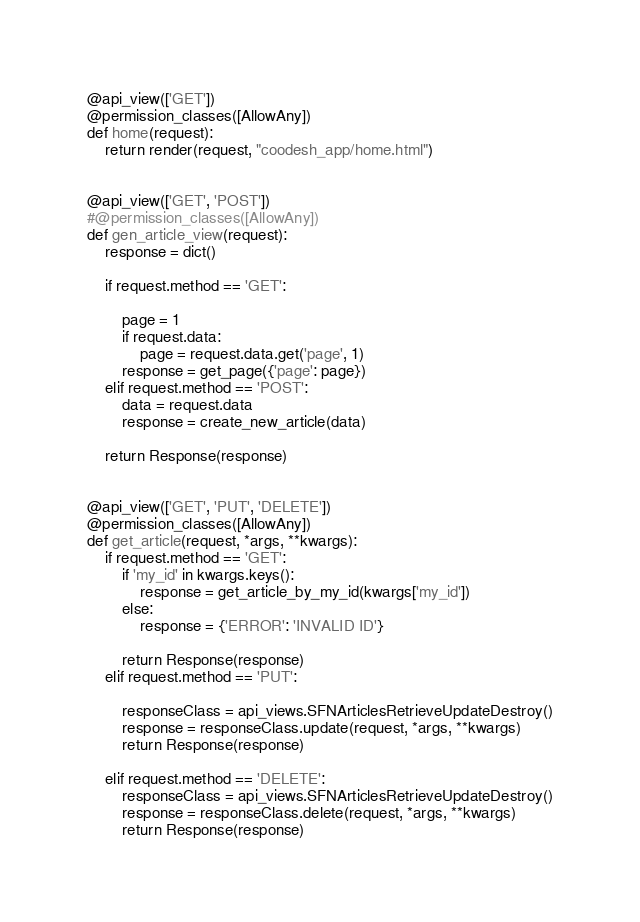Convert code to text. <code><loc_0><loc_0><loc_500><loc_500><_Python_>@api_view(['GET'])
@permission_classes([AllowAny])
def home(request):
    return render(request, "coodesh_app/home.html")


@api_view(['GET', 'POST'])
#@permission_classes([AllowAny])
def gen_article_view(request):
    response = dict()

    if request.method == 'GET':

        page = 1
        if request.data:
            page = request.data.get('page', 1)
        response = get_page({'page': page})
    elif request.method == 'POST':
        data = request.data
        response = create_new_article(data)

    return Response(response)


@api_view(['GET', 'PUT', 'DELETE'])
@permission_classes([AllowAny])
def get_article(request, *args, **kwargs):
    if request.method == 'GET':
        if 'my_id' in kwargs.keys():
            response = get_article_by_my_id(kwargs['my_id'])
        else:
            response = {'ERROR': 'INVALID ID'}

        return Response(response)
    elif request.method == 'PUT':

        responseClass = api_views.SFNArticlesRetrieveUpdateDestroy()
        response = responseClass.update(request, *args, **kwargs)
        return Response(response)

    elif request.method == 'DELETE':
        responseClass = api_views.SFNArticlesRetrieveUpdateDestroy()
        response = responseClass.delete(request, *args, **kwargs)
        return Response(response)
</code> 